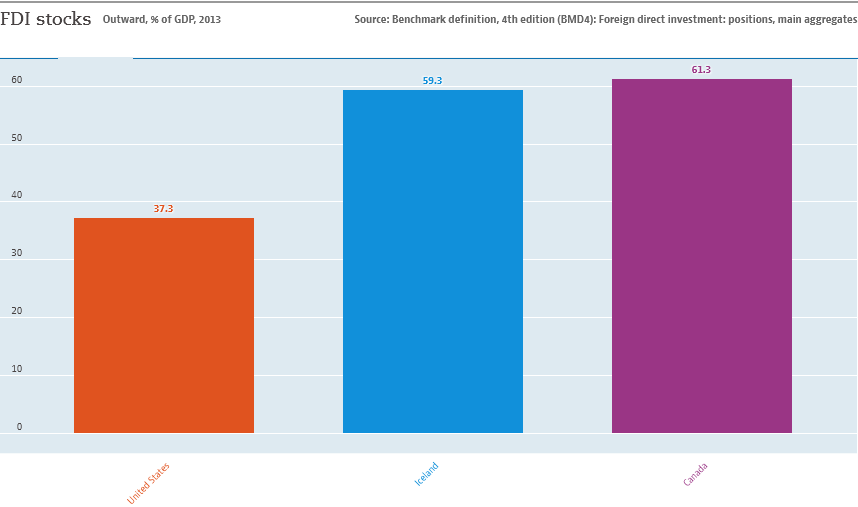Can you explain the significance of FDI stocks being higher in Canada compared to the United States and Iceland? FDI stocks, representing how much foreign investment is retained in a country's economy relative to its GDP, being higher in Canada indicates a strong international investment confidence and possibly more favorable investment policies or business environments compared to the United States and Iceland. This could be influenced by sectors attracting foreign investment or macroeconomic policies encouraging foreign business operations. 